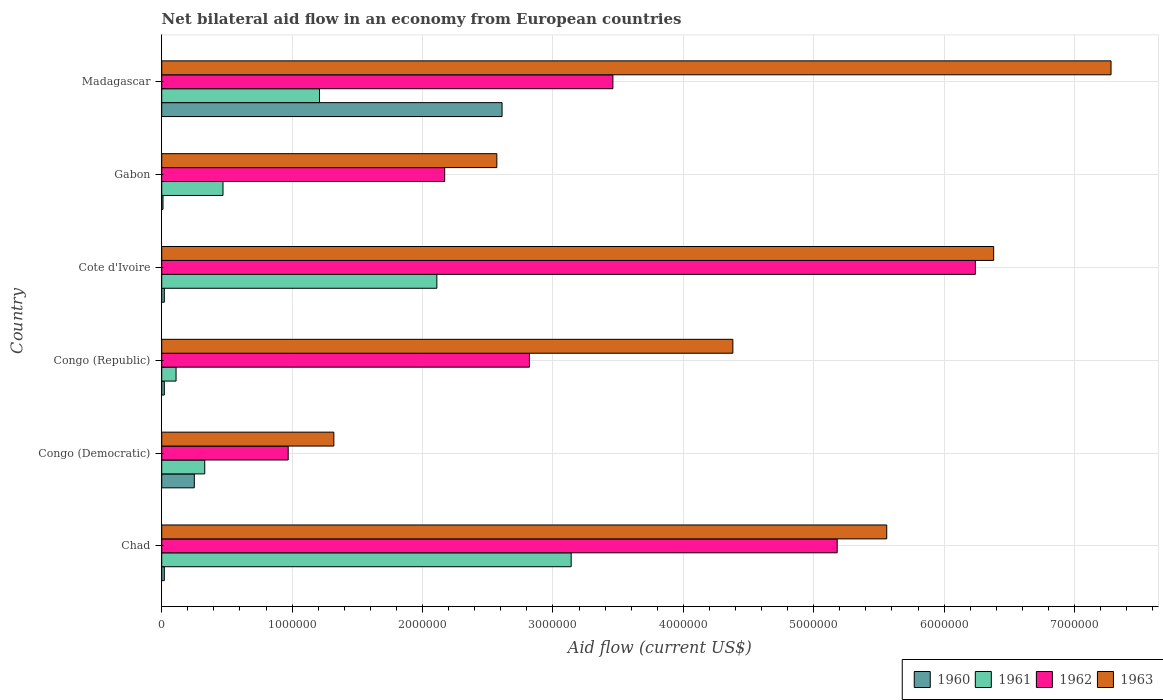How many groups of bars are there?
Provide a succinct answer. 6. Are the number of bars per tick equal to the number of legend labels?
Offer a very short reply. Yes. Are the number of bars on each tick of the Y-axis equal?
Provide a short and direct response. Yes. How many bars are there on the 5th tick from the top?
Offer a terse response. 4. What is the label of the 3rd group of bars from the top?
Your response must be concise. Cote d'Ivoire. In how many cases, is the number of bars for a given country not equal to the number of legend labels?
Your answer should be very brief. 0. What is the net bilateral aid flow in 1960 in Madagascar?
Make the answer very short. 2.61e+06. Across all countries, what is the maximum net bilateral aid flow in 1963?
Provide a short and direct response. 7.28e+06. Across all countries, what is the minimum net bilateral aid flow in 1960?
Offer a very short reply. 10000. In which country was the net bilateral aid flow in 1961 maximum?
Your answer should be compact. Chad. In which country was the net bilateral aid flow in 1961 minimum?
Keep it short and to the point. Congo (Republic). What is the total net bilateral aid flow in 1960 in the graph?
Your answer should be very brief. 2.93e+06. What is the difference between the net bilateral aid flow in 1962 in Chad and that in Congo (Republic)?
Make the answer very short. 2.36e+06. What is the difference between the net bilateral aid flow in 1963 in Gabon and the net bilateral aid flow in 1962 in Cote d'Ivoire?
Your answer should be very brief. -3.67e+06. What is the average net bilateral aid flow in 1962 per country?
Your answer should be very brief. 3.47e+06. What is the difference between the net bilateral aid flow in 1960 and net bilateral aid flow in 1961 in Madagascar?
Offer a terse response. 1.40e+06. What is the ratio of the net bilateral aid flow in 1963 in Congo (Republic) to that in Madagascar?
Ensure brevity in your answer.  0.6. Is the net bilateral aid flow in 1960 in Cote d'Ivoire less than that in Madagascar?
Your response must be concise. Yes. What is the difference between the highest and the second highest net bilateral aid flow in 1962?
Provide a short and direct response. 1.06e+06. What is the difference between the highest and the lowest net bilateral aid flow in 1960?
Ensure brevity in your answer.  2.60e+06. In how many countries, is the net bilateral aid flow in 1963 greater than the average net bilateral aid flow in 1963 taken over all countries?
Your response must be concise. 3. Is it the case that in every country, the sum of the net bilateral aid flow in 1960 and net bilateral aid flow in 1961 is greater than the net bilateral aid flow in 1963?
Your answer should be very brief. No. How many bars are there?
Provide a short and direct response. 24. Are all the bars in the graph horizontal?
Your answer should be compact. Yes. Are the values on the major ticks of X-axis written in scientific E-notation?
Offer a terse response. No. Does the graph contain any zero values?
Provide a succinct answer. No. How many legend labels are there?
Your answer should be compact. 4. What is the title of the graph?
Ensure brevity in your answer.  Net bilateral aid flow in an economy from European countries. What is the label or title of the X-axis?
Give a very brief answer. Aid flow (current US$). What is the Aid flow (current US$) in 1960 in Chad?
Your response must be concise. 2.00e+04. What is the Aid flow (current US$) of 1961 in Chad?
Your response must be concise. 3.14e+06. What is the Aid flow (current US$) in 1962 in Chad?
Offer a very short reply. 5.18e+06. What is the Aid flow (current US$) in 1963 in Chad?
Your answer should be very brief. 5.56e+06. What is the Aid flow (current US$) in 1960 in Congo (Democratic)?
Offer a very short reply. 2.50e+05. What is the Aid flow (current US$) in 1962 in Congo (Democratic)?
Make the answer very short. 9.70e+05. What is the Aid flow (current US$) in 1963 in Congo (Democratic)?
Make the answer very short. 1.32e+06. What is the Aid flow (current US$) of 1962 in Congo (Republic)?
Your answer should be compact. 2.82e+06. What is the Aid flow (current US$) in 1963 in Congo (Republic)?
Offer a terse response. 4.38e+06. What is the Aid flow (current US$) of 1960 in Cote d'Ivoire?
Provide a short and direct response. 2.00e+04. What is the Aid flow (current US$) in 1961 in Cote d'Ivoire?
Make the answer very short. 2.11e+06. What is the Aid flow (current US$) in 1962 in Cote d'Ivoire?
Your answer should be compact. 6.24e+06. What is the Aid flow (current US$) in 1963 in Cote d'Ivoire?
Keep it short and to the point. 6.38e+06. What is the Aid flow (current US$) in 1962 in Gabon?
Your response must be concise. 2.17e+06. What is the Aid flow (current US$) of 1963 in Gabon?
Your answer should be compact. 2.57e+06. What is the Aid flow (current US$) of 1960 in Madagascar?
Provide a succinct answer. 2.61e+06. What is the Aid flow (current US$) in 1961 in Madagascar?
Ensure brevity in your answer.  1.21e+06. What is the Aid flow (current US$) of 1962 in Madagascar?
Give a very brief answer. 3.46e+06. What is the Aid flow (current US$) of 1963 in Madagascar?
Offer a terse response. 7.28e+06. Across all countries, what is the maximum Aid flow (current US$) of 1960?
Your response must be concise. 2.61e+06. Across all countries, what is the maximum Aid flow (current US$) of 1961?
Offer a very short reply. 3.14e+06. Across all countries, what is the maximum Aid flow (current US$) of 1962?
Ensure brevity in your answer.  6.24e+06. Across all countries, what is the maximum Aid flow (current US$) in 1963?
Keep it short and to the point. 7.28e+06. Across all countries, what is the minimum Aid flow (current US$) in 1961?
Give a very brief answer. 1.10e+05. Across all countries, what is the minimum Aid flow (current US$) of 1962?
Offer a very short reply. 9.70e+05. Across all countries, what is the minimum Aid flow (current US$) of 1963?
Give a very brief answer. 1.32e+06. What is the total Aid flow (current US$) of 1960 in the graph?
Provide a succinct answer. 2.93e+06. What is the total Aid flow (current US$) of 1961 in the graph?
Your response must be concise. 7.37e+06. What is the total Aid flow (current US$) of 1962 in the graph?
Give a very brief answer. 2.08e+07. What is the total Aid flow (current US$) of 1963 in the graph?
Your answer should be compact. 2.75e+07. What is the difference between the Aid flow (current US$) of 1960 in Chad and that in Congo (Democratic)?
Give a very brief answer. -2.30e+05. What is the difference between the Aid flow (current US$) of 1961 in Chad and that in Congo (Democratic)?
Offer a terse response. 2.81e+06. What is the difference between the Aid flow (current US$) of 1962 in Chad and that in Congo (Democratic)?
Keep it short and to the point. 4.21e+06. What is the difference between the Aid flow (current US$) of 1963 in Chad and that in Congo (Democratic)?
Provide a succinct answer. 4.24e+06. What is the difference between the Aid flow (current US$) in 1960 in Chad and that in Congo (Republic)?
Your response must be concise. 0. What is the difference between the Aid flow (current US$) of 1961 in Chad and that in Congo (Republic)?
Provide a short and direct response. 3.03e+06. What is the difference between the Aid flow (current US$) in 1962 in Chad and that in Congo (Republic)?
Keep it short and to the point. 2.36e+06. What is the difference between the Aid flow (current US$) of 1963 in Chad and that in Congo (Republic)?
Make the answer very short. 1.18e+06. What is the difference between the Aid flow (current US$) in 1961 in Chad and that in Cote d'Ivoire?
Keep it short and to the point. 1.03e+06. What is the difference between the Aid flow (current US$) in 1962 in Chad and that in Cote d'Ivoire?
Ensure brevity in your answer.  -1.06e+06. What is the difference between the Aid flow (current US$) in 1963 in Chad and that in Cote d'Ivoire?
Keep it short and to the point. -8.20e+05. What is the difference between the Aid flow (current US$) of 1960 in Chad and that in Gabon?
Offer a very short reply. 10000. What is the difference between the Aid flow (current US$) in 1961 in Chad and that in Gabon?
Provide a succinct answer. 2.67e+06. What is the difference between the Aid flow (current US$) of 1962 in Chad and that in Gabon?
Your answer should be compact. 3.01e+06. What is the difference between the Aid flow (current US$) in 1963 in Chad and that in Gabon?
Give a very brief answer. 2.99e+06. What is the difference between the Aid flow (current US$) of 1960 in Chad and that in Madagascar?
Ensure brevity in your answer.  -2.59e+06. What is the difference between the Aid flow (current US$) in 1961 in Chad and that in Madagascar?
Ensure brevity in your answer.  1.93e+06. What is the difference between the Aid flow (current US$) in 1962 in Chad and that in Madagascar?
Provide a succinct answer. 1.72e+06. What is the difference between the Aid flow (current US$) of 1963 in Chad and that in Madagascar?
Your answer should be very brief. -1.72e+06. What is the difference between the Aid flow (current US$) in 1961 in Congo (Democratic) and that in Congo (Republic)?
Provide a short and direct response. 2.20e+05. What is the difference between the Aid flow (current US$) in 1962 in Congo (Democratic) and that in Congo (Republic)?
Your answer should be very brief. -1.85e+06. What is the difference between the Aid flow (current US$) in 1963 in Congo (Democratic) and that in Congo (Republic)?
Ensure brevity in your answer.  -3.06e+06. What is the difference between the Aid flow (current US$) in 1961 in Congo (Democratic) and that in Cote d'Ivoire?
Make the answer very short. -1.78e+06. What is the difference between the Aid flow (current US$) of 1962 in Congo (Democratic) and that in Cote d'Ivoire?
Provide a short and direct response. -5.27e+06. What is the difference between the Aid flow (current US$) in 1963 in Congo (Democratic) and that in Cote d'Ivoire?
Your answer should be compact. -5.06e+06. What is the difference between the Aid flow (current US$) in 1960 in Congo (Democratic) and that in Gabon?
Provide a short and direct response. 2.40e+05. What is the difference between the Aid flow (current US$) of 1962 in Congo (Democratic) and that in Gabon?
Offer a very short reply. -1.20e+06. What is the difference between the Aid flow (current US$) in 1963 in Congo (Democratic) and that in Gabon?
Your response must be concise. -1.25e+06. What is the difference between the Aid flow (current US$) in 1960 in Congo (Democratic) and that in Madagascar?
Offer a very short reply. -2.36e+06. What is the difference between the Aid flow (current US$) of 1961 in Congo (Democratic) and that in Madagascar?
Keep it short and to the point. -8.80e+05. What is the difference between the Aid flow (current US$) of 1962 in Congo (Democratic) and that in Madagascar?
Provide a short and direct response. -2.49e+06. What is the difference between the Aid flow (current US$) in 1963 in Congo (Democratic) and that in Madagascar?
Your response must be concise. -5.96e+06. What is the difference between the Aid flow (current US$) in 1960 in Congo (Republic) and that in Cote d'Ivoire?
Provide a short and direct response. 0. What is the difference between the Aid flow (current US$) of 1961 in Congo (Republic) and that in Cote d'Ivoire?
Keep it short and to the point. -2.00e+06. What is the difference between the Aid flow (current US$) of 1962 in Congo (Republic) and that in Cote d'Ivoire?
Keep it short and to the point. -3.42e+06. What is the difference between the Aid flow (current US$) in 1960 in Congo (Republic) and that in Gabon?
Ensure brevity in your answer.  10000. What is the difference between the Aid flow (current US$) in 1961 in Congo (Republic) and that in Gabon?
Ensure brevity in your answer.  -3.60e+05. What is the difference between the Aid flow (current US$) in 1962 in Congo (Republic) and that in Gabon?
Ensure brevity in your answer.  6.50e+05. What is the difference between the Aid flow (current US$) in 1963 in Congo (Republic) and that in Gabon?
Your answer should be very brief. 1.81e+06. What is the difference between the Aid flow (current US$) in 1960 in Congo (Republic) and that in Madagascar?
Keep it short and to the point. -2.59e+06. What is the difference between the Aid flow (current US$) in 1961 in Congo (Republic) and that in Madagascar?
Make the answer very short. -1.10e+06. What is the difference between the Aid flow (current US$) of 1962 in Congo (Republic) and that in Madagascar?
Your answer should be compact. -6.40e+05. What is the difference between the Aid flow (current US$) in 1963 in Congo (Republic) and that in Madagascar?
Provide a succinct answer. -2.90e+06. What is the difference between the Aid flow (current US$) in 1960 in Cote d'Ivoire and that in Gabon?
Keep it short and to the point. 10000. What is the difference between the Aid flow (current US$) in 1961 in Cote d'Ivoire and that in Gabon?
Make the answer very short. 1.64e+06. What is the difference between the Aid flow (current US$) of 1962 in Cote d'Ivoire and that in Gabon?
Offer a very short reply. 4.07e+06. What is the difference between the Aid flow (current US$) in 1963 in Cote d'Ivoire and that in Gabon?
Offer a very short reply. 3.81e+06. What is the difference between the Aid flow (current US$) in 1960 in Cote d'Ivoire and that in Madagascar?
Keep it short and to the point. -2.59e+06. What is the difference between the Aid flow (current US$) of 1962 in Cote d'Ivoire and that in Madagascar?
Your answer should be compact. 2.78e+06. What is the difference between the Aid flow (current US$) of 1963 in Cote d'Ivoire and that in Madagascar?
Keep it short and to the point. -9.00e+05. What is the difference between the Aid flow (current US$) in 1960 in Gabon and that in Madagascar?
Your answer should be compact. -2.60e+06. What is the difference between the Aid flow (current US$) of 1961 in Gabon and that in Madagascar?
Your answer should be very brief. -7.40e+05. What is the difference between the Aid flow (current US$) of 1962 in Gabon and that in Madagascar?
Provide a short and direct response. -1.29e+06. What is the difference between the Aid flow (current US$) in 1963 in Gabon and that in Madagascar?
Give a very brief answer. -4.71e+06. What is the difference between the Aid flow (current US$) of 1960 in Chad and the Aid flow (current US$) of 1961 in Congo (Democratic)?
Make the answer very short. -3.10e+05. What is the difference between the Aid flow (current US$) in 1960 in Chad and the Aid flow (current US$) in 1962 in Congo (Democratic)?
Your answer should be compact. -9.50e+05. What is the difference between the Aid flow (current US$) in 1960 in Chad and the Aid flow (current US$) in 1963 in Congo (Democratic)?
Offer a very short reply. -1.30e+06. What is the difference between the Aid flow (current US$) in 1961 in Chad and the Aid flow (current US$) in 1962 in Congo (Democratic)?
Offer a very short reply. 2.17e+06. What is the difference between the Aid flow (current US$) of 1961 in Chad and the Aid flow (current US$) of 1963 in Congo (Democratic)?
Ensure brevity in your answer.  1.82e+06. What is the difference between the Aid flow (current US$) in 1962 in Chad and the Aid flow (current US$) in 1963 in Congo (Democratic)?
Provide a short and direct response. 3.86e+06. What is the difference between the Aid flow (current US$) of 1960 in Chad and the Aid flow (current US$) of 1962 in Congo (Republic)?
Your answer should be compact. -2.80e+06. What is the difference between the Aid flow (current US$) in 1960 in Chad and the Aid flow (current US$) in 1963 in Congo (Republic)?
Ensure brevity in your answer.  -4.36e+06. What is the difference between the Aid flow (current US$) in 1961 in Chad and the Aid flow (current US$) in 1963 in Congo (Republic)?
Your answer should be compact. -1.24e+06. What is the difference between the Aid flow (current US$) in 1960 in Chad and the Aid flow (current US$) in 1961 in Cote d'Ivoire?
Give a very brief answer. -2.09e+06. What is the difference between the Aid flow (current US$) of 1960 in Chad and the Aid flow (current US$) of 1962 in Cote d'Ivoire?
Offer a terse response. -6.22e+06. What is the difference between the Aid flow (current US$) of 1960 in Chad and the Aid flow (current US$) of 1963 in Cote d'Ivoire?
Your response must be concise. -6.36e+06. What is the difference between the Aid flow (current US$) of 1961 in Chad and the Aid flow (current US$) of 1962 in Cote d'Ivoire?
Ensure brevity in your answer.  -3.10e+06. What is the difference between the Aid flow (current US$) of 1961 in Chad and the Aid flow (current US$) of 1963 in Cote d'Ivoire?
Ensure brevity in your answer.  -3.24e+06. What is the difference between the Aid flow (current US$) in 1962 in Chad and the Aid flow (current US$) in 1963 in Cote d'Ivoire?
Provide a succinct answer. -1.20e+06. What is the difference between the Aid flow (current US$) in 1960 in Chad and the Aid flow (current US$) in 1961 in Gabon?
Provide a short and direct response. -4.50e+05. What is the difference between the Aid flow (current US$) of 1960 in Chad and the Aid flow (current US$) of 1962 in Gabon?
Your answer should be very brief. -2.15e+06. What is the difference between the Aid flow (current US$) of 1960 in Chad and the Aid flow (current US$) of 1963 in Gabon?
Your answer should be compact. -2.55e+06. What is the difference between the Aid flow (current US$) of 1961 in Chad and the Aid flow (current US$) of 1962 in Gabon?
Make the answer very short. 9.70e+05. What is the difference between the Aid flow (current US$) of 1961 in Chad and the Aid flow (current US$) of 1963 in Gabon?
Provide a short and direct response. 5.70e+05. What is the difference between the Aid flow (current US$) in 1962 in Chad and the Aid flow (current US$) in 1963 in Gabon?
Your answer should be compact. 2.61e+06. What is the difference between the Aid flow (current US$) of 1960 in Chad and the Aid flow (current US$) of 1961 in Madagascar?
Give a very brief answer. -1.19e+06. What is the difference between the Aid flow (current US$) of 1960 in Chad and the Aid flow (current US$) of 1962 in Madagascar?
Ensure brevity in your answer.  -3.44e+06. What is the difference between the Aid flow (current US$) of 1960 in Chad and the Aid flow (current US$) of 1963 in Madagascar?
Offer a terse response. -7.26e+06. What is the difference between the Aid flow (current US$) in 1961 in Chad and the Aid flow (current US$) in 1962 in Madagascar?
Your answer should be compact. -3.20e+05. What is the difference between the Aid flow (current US$) in 1961 in Chad and the Aid flow (current US$) in 1963 in Madagascar?
Ensure brevity in your answer.  -4.14e+06. What is the difference between the Aid flow (current US$) in 1962 in Chad and the Aid flow (current US$) in 1963 in Madagascar?
Keep it short and to the point. -2.10e+06. What is the difference between the Aid flow (current US$) in 1960 in Congo (Democratic) and the Aid flow (current US$) in 1961 in Congo (Republic)?
Make the answer very short. 1.40e+05. What is the difference between the Aid flow (current US$) in 1960 in Congo (Democratic) and the Aid flow (current US$) in 1962 in Congo (Republic)?
Offer a terse response. -2.57e+06. What is the difference between the Aid flow (current US$) of 1960 in Congo (Democratic) and the Aid flow (current US$) of 1963 in Congo (Republic)?
Your answer should be very brief. -4.13e+06. What is the difference between the Aid flow (current US$) of 1961 in Congo (Democratic) and the Aid flow (current US$) of 1962 in Congo (Republic)?
Keep it short and to the point. -2.49e+06. What is the difference between the Aid flow (current US$) in 1961 in Congo (Democratic) and the Aid flow (current US$) in 1963 in Congo (Republic)?
Give a very brief answer. -4.05e+06. What is the difference between the Aid flow (current US$) of 1962 in Congo (Democratic) and the Aid flow (current US$) of 1963 in Congo (Republic)?
Keep it short and to the point. -3.41e+06. What is the difference between the Aid flow (current US$) of 1960 in Congo (Democratic) and the Aid flow (current US$) of 1961 in Cote d'Ivoire?
Your response must be concise. -1.86e+06. What is the difference between the Aid flow (current US$) in 1960 in Congo (Democratic) and the Aid flow (current US$) in 1962 in Cote d'Ivoire?
Keep it short and to the point. -5.99e+06. What is the difference between the Aid flow (current US$) of 1960 in Congo (Democratic) and the Aid flow (current US$) of 1963 in Cote d'Ivoire?
Offer a terse response. -6.13e+06. What is the difference between the Aid flow (current US$) of 1961 in Congo (Democratic) and the Aid flow (current US$) of 1962 in Cote d'Ivoire?
Provide a short and direct response. -5.91e+06. What is the difference between the Aid flow (current US$) in 1961 in Congo (Democratic) and the Aid flow (current US$) in 1963 in Cote d'Ivoire?
Your answer should be very brief. -6.05e+06. What is the difference between the Aid flow (current US$) in 1962 in Congo (Democratic) and the Aid flow (current US$) in 1963 in Cote d'Ivoire?
Offer a terse response. -5.41e+06. What is the difference between the Aid flow (current US$) in 1960 in Congo (Democratic) and the Aid flow (current US$) in 1961 in Gabon?
Your answer should be compact. -2.20e+05. What is the difference between the Aid flow (current US$) in 1960 in Congo (Democratic) and the Aid flow (current US$) in 1962 in Gabon?
Give a very brief answer. -1.92e+06. What is the difference between the Aid flow (current US$) of 1960 in Congo (Democratic) and the Aid flow (current US$) of 1963 in Gabon?
Provide a succinct answer. -2.32e+06. What is the difference between the Aid flow (current US$) in 1961 in Congo (Democratic) and the Aid flow (current US$) in 1962 in Gabon?
Your response must be concise. -1.84e+06. What is the difference between the Aid flow (current US$) of 1961 in Congo (Democratic) and the Aid flow (current US$) of 1963 in Gabon?
Offer a terse response. -2.24e+06. What is the difference between the Aid flow (current US$) in 1962 in Congo (Democratic) and the Aid flow (current US$) in 1963 in Gabon?
Provide a short and direct response. -1.60e+06. What is the difference between the Aid flow (current US$) in 1960 in Congo (Democratic) and the Aid flow (current US$) in 1961 in Madagascar?
Give a very brief answer. -9.60e+05. What is the difference between the Aid flow (current US$) in 1960 in Congo (Democratic) and the Aid flow (current US$) in 1962 in Madagascar?
Provide a short and direct response. -3.21e+06. What is the difference between the Aid flow (current US$) of 1960 in Congo (Democratic) and the Aid flow (current US$) of 1963 in Madagascar?
Give a very brief answer. -7.03e+06. What is the difference between the Aid flow (current US$) in 1961 in Congo (Democratic) and the Aid flow (current US$) in 1962 in Madagascar?
Ensure brevity in your answer.  -3.13e+06. What is the difference between the Aid flow (current US$) of 1961 in Congo (Democratic) and the Aid flow (current US$) of 1963 in Madagascar?
Offer a terse response. -6.95e+06. What is the difference between the Aid flow (current US$) in 1962 in Congo (Democratic) and the Aid flow (current US$) in 1963 in Madagascar?
Offer a terse response. -6.31e+06. What is the difference between the Aid flow (current US$) in 1960 in Congo (Republic) and the Aid flow (current US$) in 1961 in Cote d'Ivoire?
Provide a short and direct response. -2.09e+06. What is the difference between the Aid flow (current US$) of 1960 in Congo (Republic) and the Aid flow (current US$) of 1962 in Cote d'Ivoire?
Make the answer very short. -6.22e+06. What is the difference between the Aid flow (current US$) in 1960 in Congo (Republic) and the Aid flow (current US$) in 1963 in Cote d'Ivoire?
Your answer should be very brief. -6.36e+06. What is the difference between the Aid flow (current US$) in 1961 in Congo (Republic) and the Aid flow (current US$) in 1962 in Cote d'Ivoire?
Provide a short and direct response. -6.13e+06. What is the difference between the Aid flow (current US$) of 1961 in Congo (Republic) and the Aid flow (current US$) of 1963 in Cote d'Ivoire?
Your response must be concise. -6.27e+06. What is the difference between the Aid flow (current US$) in 1962 in Congo (Republic) and the Aid flow (current US$) in 1963 in Cote d'Ivoire?
Your answer should be very brief. -3.56e+06. What is the difference between the Aid flow (current US$) of 1960 in Congo (Republic) and the Aid flow (current US$) of 1961 in Gabon?
Offer a terse response. -4.50e+05. What is the difference between the Aid flow (current US$) in 1960 in Congo (Republic) and the Aid flow (current US$) in 1962 in Gabon?
Offer a very short reply. -2.15e+06. What is the difference between the Aid flow (current US$) of 1960 in Congo (Republic) and the Aid flow (current US$) of 1963 in Gabon?
Make the answer very short. -2.55e+06. What is the difference between the Aid flow (current US$) of 1961 in Congo (Republic) and the Aid flow (current US$) of 1962 in Gabon?
Give a very brief answer. -2.06e+06. What is the difference between the Aid flow (current US$) in 1961 in Congo (Republic) and the Aid flow (current US$) in 1963 in Gabon?
Offer a terse response. -2.46e+06. What is the difference between the Aid flow (current US$) of 1962 in Congo (Republic) and the Aid flow (current US$) of 1963 in Gabon?
Provide a short and direct response. 2.50e+05. What is the difference between the Aid flow (current US$) in 1960 in Congo (Republic) and the Aid flow (current US$) in 1961 in Madagascar?
Give a very brief answer. -1.19e+06. What is the difference between the Aid flow (current US$) of 1960 in Congo (Republic) and the Aid flow (current US$) of 1962 in Madagascar?
Your answer should be very brief. -3.44e+06. What is the difference between the Aid flow (current US$) in 1960 in Congo (Republic) and the Aid flow (current US$) in 1963 in Madagascar?
Provide a short and direct response. -7.26e+06. What is the difference between the Aid flow (current US$) of 1961 in Congo (Republic) and the Aid flow (current US$) of 1962 in Madagascar?
Provide a succinct answer. -3.35e+06. What is the difference between the Aid flow (current US$) of 1961 in Congo (Republic) and the Aid flow (current US$) of 1963 in Madagascar?
Your answer should be very brief. -7.17e+06. What is the difference between the Aid flow (current US$) of 1962 in Congo (Republic) and the Aid flow (current US$) of 1963 in Madagascar?
Give a very brief answer. -4.46e+06. What is the difference between the Aid flow (current US$) of 1960 in Cote d'Ivoire and the Aid flow (current US$) of 1961 in Gabon?
Make the answer very short. -4.50e+05. What is the difference between the Aid flow (current US$) of 1960 in Cote d'Ivoire and the Aid flow (current US$) of 1962 in Gabon?
Give a very brief answer. -2.15e+06. What is the difference between the Aid flow (current US$) in 1960 in Cote d'Ivoire and the Aid flow (current US$) in 1963 in Gabon?
Your response must be concise. -2.55e+06. What is the difference between the Aid flow (current US$) of 1961 in Cote d'Ivoire and the Aid flow (current US$) of 1962 in Gabon?
Give a very brief answer. -6.00e+04. What is the difference between the Aid flow (current US$) in 1961 in Cote d'Ivoire and the Aid flow (current US$) in 1963 in Gabon?
Your response must be concise. -4.60e+05. What is the difference between the Aid flow (current US$) of 1962 in Cote d'Ivoire and the Aid flow (current US$) of 1963 in Gabon?
Your response must be concise. 3.67e+06. What is the difference between the Aid flow (current US$) in 1960 in Cote d'Ivoire and the Aid flow (current US$) in 1961 in Madagascar?
Keep it short and to the point. -1.19e+06. What is the difference between the Aid flow (current US$) of 1960 in Cote d'Ivoire and the Aid flow (current US$) of 1962 in Madagascar?
Ensure brevity in your answer.  -3.44e+06. What is the difference between the Aid flow (current US$) in 1960 in Cote d'Ivoire and the Aid flow (current US$) in 1963 in Madagascar?
Keep it short and to the point. -7.26e+06. What is the difference between the Aid flow (current US$) in 1961 in Cote d'Ivoire and the Aid flow (current US$) in 1962 in Madagascar?
Offer a terse response. -1.35e+06. What is the difference between the Aid flow (current US$) in 1961 in Cote d'Ivoire and the Aid flow (current US$) in 1963 in Madagascar?
Give a very brief answer. -5.17e+06. What is the difference between the Aid flow (current US$) in 1962 in Cote d'Ivoire and the Aid flow (current US$) in 1963 in Madagascar?
Your answer should be very brief. -1.04e+06. What is the difference between the Aid flow (current US$) in 1960 in Gabon and the Aid flow (current US$) in 1961 in Madagascar?
Keep it short and to the point. -1.20e+06. What is the difference between the Aid flow (current US$) of 1960 in Gabon and the Aid flow (current US$) of 1962 in Madagascar?
Provide a short and direct response. -3.45e+06. What is the difference between the Aid flow (current US$) in 1960 in Gabon and the Aid flow (current US$) in 1963 in Madagascar?
Give a very brief answer. -7.27e+06. What is the difference between the Aid flow (current US$) of 1961 in Gabon and the Aid flow (current US$) of 1962 in Madagascar?
Your response must be concise. -2.99e+06. What is the difference between the Aid flow (current US$) of 1961 in Gabon and the Aid flow (current US$) of 1963 in Madagascar?
Make the answer very short. -6.81e+06. What is the difference between the Aid flow (current US$) of 1962 in Gabon and the Aid flow (current US$) of 1963 in Madagascar?
Keep it short and to the point. -5.11e+06. What is the average Aid flow (current US$) in 1960 per country?
Keep it short and to the point. 4.88e+05. What is the average Aid flow (current US$) of 1961 per country?
Your response must be concise. 1.23e+06. What is the average Aid flow (current US$) of 1962 per country?
Provide a short and direct response. 3.47e+06. What is the average Aid flow (current US$) in 1963 per country?
Your answer should be compact. 4.58e+06. What is the difference between the Aid flow (current US$) of 1960 and Aid flow (current US$) of 1961 in Chad?
Ensure brevity in your answer.  -3.12e+06. What is the difference between the Aid flow (current US$) in 1960 and Aid flow (current US$) in 1962 in Chad?
Make the answer very short. -5.16e+06. What is the difference between the Aid flow (current US$) of 1960 and Aid flow (current US$) of 1963 in Chad?
Provide a succinct answer. -5.54e+06. What is the difference between the Aid flow (current US$) of 1961 and Aid flow (current US$) of 1962 in Chad?
Offer a terse response. -2.04e+06. What is the difference between the Aid flow (current US$) of 1961 and Aid flow (current US$) of 1963 in Chad?
Your answer should be very brief. -2.42e+06. What is the difference between the Aid flow (current US$) of 1962 and Aid flow (current US$) of 1963 in Chad?
Your response must be concise. -3.80e+05. What is the difference between the Aid flow (current US$) of 1960 and Aid flow (current US$) of 1962 in Congo (Democratic)?
Offer a very short reply. -7.20e+05. What is the difference between the Aid flow (current US$) in 1960 and Aid flow (current US$) in 1963 in Congo (Democratic)?
Offer a very short reply. -1.07e+06. What is the difference between the Aid flow (current US$) in 1961 and Aid flow (current US$) in 1962 in Congo (Democratic)?
Provide a short and direct response. -6.40e+05. What is the difference between the Aid flow (current US$) in 1961 and Aid flow (current US$) in 1963 in Congo (Democratic)?
Your answer should be very brief. -9.90e+05. What is the difference between the Aid flow (current US$) of 1962 and Aid flow (current US$) of 1963 in Congo (Democratic)?
Give a very brief answer. -3.50e+05. What is the difference between the Aid flow (current US$) in 1960 and Aid flow (current US$) in 1962 in Congo (Republic)?
Make the answer very short. -2.80e+06. What is the difference between the Aid flow (current US$) of 1960 and Aid flow (current US$) of 1963 in Congo (Republic)?
Your answer should be compact. -4.36e+06. What is the difference between the Aid flow (current US$) of 1961 and Aid flow (current US$) of 1962 in Congo (Republic)?
Provide a succinct answer. -2.71e+06. What is the difference between the Aid flow (current US$) of 1961 and Aid flow (current US$) of 1963 in Congo (Republic)?
Make the answer very short. -4.27e+06. What is the difference between the Aid flow (current US$) in 1962 and Aid flow (current US$) in 1963 in Congo (Republic)?
Make the answer very short. -1.56e+06. What is the difference between the Aid flow (current US$) of 1960 and Aid flow (current US$) of 1961 in Cote d'Ivoire?
Your answer should be very brief. -2.09e+06. What is the difference between the Aid flow (current US$) in 1960 and Aid flow (current US$) in 1962 in Cote d'Ivoire?
Your response must be concise. -6.22e+06. What is the difference between the Aid flow (current US$) of 1960 and Aid flow (current US$) of 1963 in Cote d'Ivoire?
Give a very brief answer. -6.36e+06. What is the difference between the Aid flow (current US$) in 1961 and Aid flow (current US$) in 1962 in Cote d'Ivoire?
Keep it short and to the point. -4.13e+06. What is the difference between the Aid flow (current US$) in 1961 and Aid flow (current US$) in 1963 in Cote d'Ivoire?
Give a very brief answer. -4.27e+06. What is the difference between the Aid flow (current US$) in 1962 and Aid flow (current US$) in 1963 in Cote d'Ivoire?
Your answer should be compact. -1.40e+05. What is the difference between the Aid flow (current US$) of 1960 and Aid flow (current US$) of 1961 in Gabon?
Your response must be concise. -4.60e+05. What is the difference between the Aid flow (current US$) of 1960 and Aid flow (current US$) of 1962 in Gabon?
Your answer should be very brief. -2.16e+06. What is the difference between the Aid flow (current US$) in 1960 and Aid flow (current US$) in 1963 in Gabon?
Your answer should be very brief. -2.56e+06. What is the difference between the Aid flow (current US$) in 1961 and Aid flow (current US$) in 1962 in Gabon?
Give a very brief answer. -1.70e+06. What is the difference between the Aid flow (current US$) in 1961 and Aid flow (current US$) in 1963 in Gabon?
Your answer should be very brief. -2.10e+06. What is the difference between the Aid flow (current US$) of 1962 and Aid flow (current US$) of 1963 in Gabon?
Make the answer very short. -4.00e+05. What is the difference between the Aid flow (current US$) of 1960 and Aid flow (current US$) of 1961 in Madagascar?
Give a very brief answer. 1.40e+06. What is the difference between the Aid flow (current US$) of 1960 and Aid flow (current US$) of 1962 in Madagascar?
Ensure brevity in your answer.  -8.50e+05. What is the difference between the Aid flow (current US$) in 1960 and Aid flow (current US$) in 1963 in Madagascar?
Offer a terse response. -4.67e+06. What is the difference between the Aid flow (current US$) in 1961 and Aid flow (current US$) in 1962 in Madagascar?
Give a very brief answer. -2.25e+06. What is the difference between the Aid flow (current US$) in 1961 and Aid flow (current US$) in 1963 in Madagascar?
Keep it short and to the point. -6.07e+06. What is the difference between the Aid flow (current US$) of 1962 and Aid flow (current US$) of 1963 in Madagascar?
Make the answer very short. -3.82e+06. What is the ratio of the Aid flow (current US$) of 1961 in Chad to that in Congo (Democratic)?
Offer a terse response. 9.52. What is the ratio of the Aid flow (current US$) in 1962 in Chad to that in Congo (Democratic)?
Provide a succinct answer. 5.34. What is the ratio of the Aid flow (current US$) in 1963 in Chad to that in Congo (Democratic)?
Your answer should be very brief. 4.21. What is the ratio of the Aid flow (current US$) of 1960 in Chad to that in Congo (Republic)?
Provide a short and direct response. 1. What is the ratio of the Aid flow (current US$) of 1961 in Chad to that in Congo (Republic)?
Your response must be concise. 28.55. What is the ratio of the Aid flow (current US$) in 1962 in Chad to that in Congo (Republic)?
Ensure brevity in your answer.  1.84. What is the ratio of the Aid flow (current US$) of 1963 in Chad to that in Congo (Republic)?
Provide a short and direct response. 1.27. What is the ratio of the Aid flow (current US$) of 1961 in Chad to that in Cote d'Ivoire?
Offer a very short reply. 1.49. What is the ratio of the Aid flow (current US$) in 1962 in Chad to that in Cote d'Ivoire?
Offer a very short reply. 0.83. What is the ratio of the Aid flow (current US$) of 1963 in Chad to that in Cote d'Ivoire?
Provide a short and direct response. 0.87. What is the ratio of the Aid flow (current US$) of 1961 in Chad to that in Gabon?
Provide a short and direct response. 6.68. What is the ratio of the Aid flow (current US$) in 1962 in Chad to that in Gabon?
Give a very brief answer. 2.39. What is the ratio of the Aid flow (current US$) of 1963 in Chad to that in Gabon?
Offer a very short reply. 2.16. What is the ratio of the Aid flow (current US$) of 1960 in Chad to that in Madagascar?
Your response must be concise. 0.01. What is the ratio of the Aid flow (current US$) in 1961 in Chad to that in Madagascar?
Provide a succinct answer. 2.6. What is the ratio of the Aid flow (current US$) of 1962 in Chad to that in Madagascar?
Offer a very short reply. 1.5. What is the ratio of the Aid flow (current US$) of 1963 in Chad to that in Madagascar?
Give a very brief answer. 0.76. What is the ratio of the Aid flow (current US$) of 1960 in Congo (Democratic) to that in Congo (Republic)?
Ensure brevity in your answer.  12.5. What is the ratio of the Aid flow (current US$) in 1962 in Congo (Democratic) to that in Congo (Republic)?
Provide a succinct answer. 0.34. What is the ratio of the Aid flow (current US$) in 1963 in Congo (Democratic) to that in Congo (Republic)?
Provide a short and direct response. 0.3. What is the ratio of the Aid flow (current US$) of 1960 in Congo (Democratic) to that in Cote d'Ivoire?
Ensure brevity in your answer.  12.5. What is the ratio of the Aid flow (current US$) in 1961 in Congo (Democratic) to that in Cote d'Ivoire?
Offer a very short reply. 0.16. What is the ratio of the Aid flow (current US$) in 1962 in Congo (Democratic) to that in Cote d'Ivoire?
Your response must be concise. 0.16. What is the ratio of the Aid flow (current US$) in 1963 in Congo (Democratic) to that in Cote d'Ivoire?
Offer a very short reply. 0.21. What is the ratio of the Aid flow (current US$) of 1961 in Congo (Democratic) to that in Gabon?
Your answer should be very brief. 0.7. What is the ratio of the Aid flow (current US$) in 1962 in Congo (Democratic) to that in Gabon?
Give a very brief answer. 0.45. What is the ratio of the Aid flow (current US$) in 1963 in Congo (Democratic) to that in Gabon?
Make the answer very short. 0.51. What is the ratio of the Aid flow (current US$) in 1960 in Congo (Democratic) to that in Madagascar?
Offer a terse response. 0.1. What is the ratio of the Aid flow (current US$) in 1961 in Congo (Democratic) to that in Madagascar?
Offer a terse response. 0.27. What is the ratio of the Aid flow (current US$) in 1962 in Congo (Democratic) to that in Madagascar?
Provide a succinct answer. 0.28. What is the ratio of the Aid flow (current US$) of 1963 in Congo (Democratic) to that in Madagascar?
Offer a terse response. 0.18. What is the ratio of the Aid flow (current US$) of 1960 in Congo (Republic) to that in Cote d'Ivoire?
Make the answer very short. 1. What is the ratio of the Aid flow (current US$) in 1961 in Congo (Republic) to that in Cote d'Ivoire?
Offer a terse response. 0.05. What is the ratio of the Aid flow (current US$) in 1962 in Congo (Republic) to that in Cote d'Ivoire?
Give a very brief answer. 0.45. What is the ratio of the Aid flow (current US$) in 1963 in Congo (Republic) to that in Cote d'Ivoire?
Your answer should be compact. 0.69. What is the ratio of the Aid flow (current US$) of 1960 in Congo (Republic) to that in Gabon?
Give a very brief answer. 2. What is the ratio of the Aid flow (current US$) of 1961 in Congo (Republic) to that in Gabon?
Your response must be concise. 0.23. What is the ratio of the Aid flow (current US$) in 1962 in Congo (Republic) to that in Gabon?
Make the answer very short. 1.3. What is the ratio of the Aid flow (current US$) of 1963 in Congo (Republic) to that in Gabon?
Keep it short and to the point. 1.7. What is the ratio of the Aid flow (current US$) in 1960 in Congo (Republic) to that in Madagascar?
Give a very brief answer. 0.01. What is the ratio of the Aid flow (current US$) of 1961 in Congo (Republic) to that in Madagascar?
Your response must be concise. 0.09. What is the ratio of the Aid flow (current US$) of 1962 in Congo (Republic) to that in Madagascar?
Your answer should be compact. 0.81. What is the ratio of the Aid flow (current US$) in 1963 in Congo (Republic) to that in Madagascar?
Your response must be concise. 0.6. What is the ratio of the Aid flow (current US$) in 1961 in Cote d'Ivoire to that in Gabon?
Keep it short and to the point. 4.49. What is the ratio of the Aid flow (current US$) of 1962 in Cote d'Ivoire to that in Gabon?
Provide a succinct answer. 2.88. What is the ratio of the Aid flow (current US$) in 1963 in Cote d'Ivoire to that in Gabon?
Provide a short and direct response. 2.48. What is the ratio of the Aid flow (current US$) of 1960 in Cote d'Ivoire to that in Madagascar?
Make the answer very short. 0.01. What is the ratio of the Aid flow (current US$) in 1961 in Cote d'Ivoire to that in Madagascar?
Give a very brief answer. 1.74. What is the ratio of the Aid flow (current US$) in 1962 in Cote d'Ivoire to that in Madagascar?
Provide a short and direct response. 1.8. What is the ratio of the Aid flow (current US$) of 1963 in Cote d'Ivoire to that in Madagascar?
Make the answer very short. 0.88. What is the ratio of the Aid flow (current US$) in 1960 in Gabon to that in Madagascar?
Give a very brief answer. 0. What is the ratio of the Aid flow (current US$) in 1961 in Gabon to that in Madagascar?
Offer a very short reply. 0.39. What is the ratio of the Aid flow (current US$) of 1962 in Gabon to that in Madagascar?
Give a very brief answer. 0.63. What is the ratio of the Aid flow (current US$) of 1963 in Gabon to that in Madagascar?
Provide a succinct answer. 0.35. What is the difference between the highest and the second highest Aid flow (current US$) in 1960?
Keep it short and to the point. 2.36e+06. What is the difference between the highest and the second highest Aid flow (current US$) of 1961?
Provide a succinct answer. 1.03e+06. What is the difference between the highest and the second highest Aid flow (current US$) of 1962?
Your answer should be compact. 1.06e+06. What is the difference between the highest and the lowest Aid flow (current US$) in 1960?
Offer a terse response. 2.60e+06. What is the difference between the highest and the lowest Aid flow (current US$) of 1961?
Your answer should be compact. 3.03e+06. What is the difference between the highest and the lowest Aid flow (current US$) of 1962?
Provide a succinct answer. 5.27e+06. What is the difference between the highest and the lowest Aid flow (current US$) of 1963?
Provide a succinct answer. 5.96e+06. 